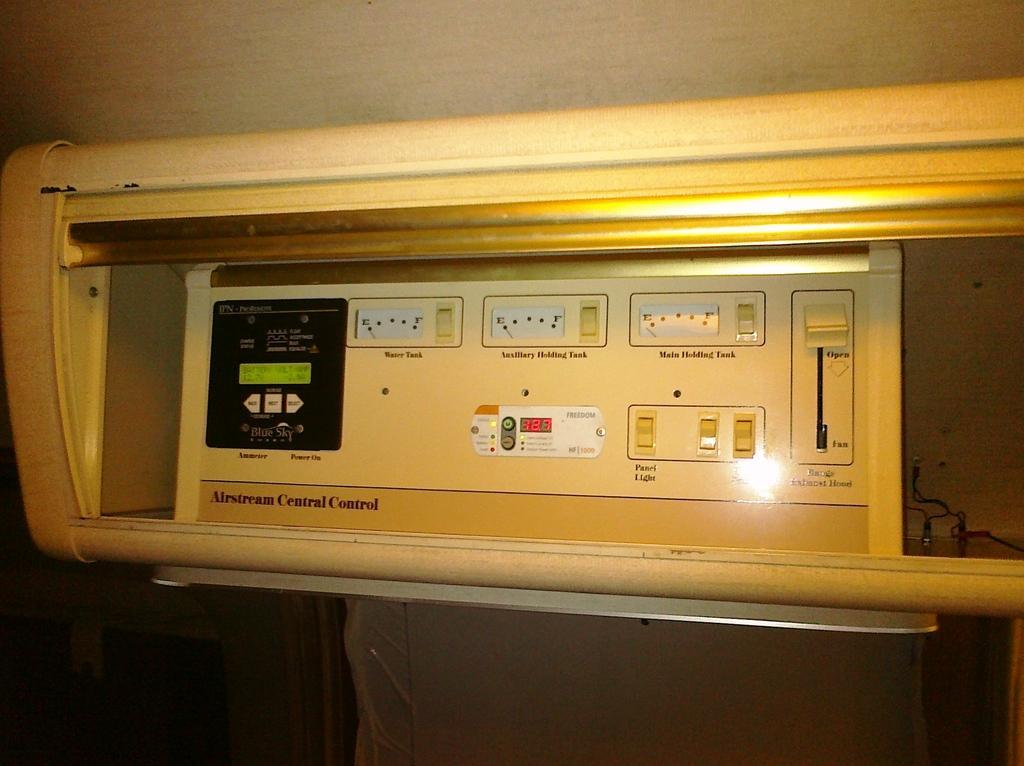Can you describe this image briefly? In this image, we can see an electrical object, we can see the wires on the right side. 